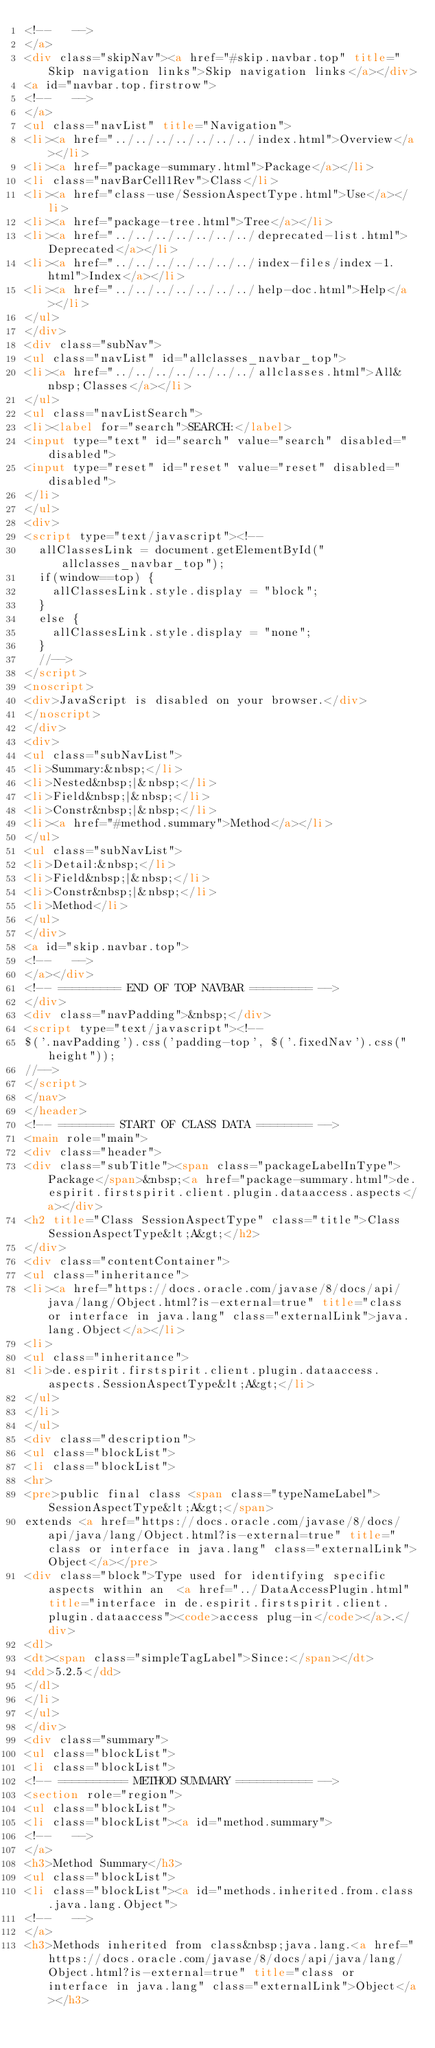Convert code to text. <code><loc_0><loc_0><loc_500><loc_500><_HTML_><!--   -->
</a>
<div class="skipNav"><a href="#skip.navbar.top" title="Skip navigation links">Skip navigation links</a></div>
<a id="navbar.top.firstrow">
<!--   -->
</a>
<ul class="navList" title="Navigation">
<li><a href="../../../../../../../index.html">Overview</a></li>
<li><a href="package-summary.html">Package</a></li>
<li class="navBarCell1Rev">Class</li>
<li><a href="class-use/SessionAspectType.html">Use</a></li>
<li><a href="package-tree.html">Tree</a></li>
<li><a href="../../../../../../../deprecated-list.html">Deprecated</a></li>
<li><a href="../../../../../../../index-files/index-1.html">Index</a></li>
<li><a href="../../../../../../../help-doc.html">Help</a></li>
</ul>
</div>
<div class="subNav">
<ul class="navList" id="allclasses_navbar_top">
<li><a href="../../../../../../../allclasses.html">All&nbsp;Classes</a></li>
</ul>
<ul class="navListSearch">
<li><label for="search">SEARCH:</label>
<input type="text" id="search" value="search" disabled="disabled">
<input type="reset" id="reset" value="reset" disabled="disabled">
</li>
</ul>
<div>
<script type="text/javascript"><!--
  allClassesLink = document.getElementById("allclasses_navbar_top");
  if(window==top) {
    allClassesLink.style.display = "block";
  }
  else {
    allClassesLink.style.display = "none";
  }
  //-->
</script>
<noscript>
<div>JavaScript is disabled on your browser.</div>
</noscript>
</div>
<div>
<ul class="subNavList">
<li>Summary:&nbsp;</li>
<li>Nested&nbsp;|&nbsp;</li>
<li>Field&nbsp;|&nbsp;</li>
<li>Constr&nbsp;|&nbsp;</li>
<li><a href="#method.summary">Method</a></li>
</ul>
<ul class="subNavList">
<li>Detail:&nbsp;</li>
<li>Field&nbsp;|&nbsp;</li>
<li>Constr&nbsp;|&nbsp;</li>
<li>Method</li>
</ul>
</div>
<a id="skip.navbar.top">
<!--   -->
</a></div>
<!-- ========= END OF TOP NAVBAR ========= -->
</div>
<div class="navPadding">&nbsp;</div>
<script type="text/javascript"><!--
$('.navPadding').css('padding-top', $('.fixedNav').css("height"));
//-->
</script>
</nav>
</header>
<!-- ======== START OF CLASS DATA ======== -->
<main role="main">
<div class="header">
<div class="subTitle"><span class="packageLabelInType">Package</span>&nbsp;<a href="package-summary.html">de.espirit.firstspirit.client.plugin.dataaccess.aspects</a></div>
<h2 title="Class SessionAspectType" class="title">Class SessionAspectType&lt;A&gt;</h2>
</div>
<div class="contentContainer">
<ul class="inheritance">
<li><a href="https://docs.oracle.com/javase/8/docs/api/java/lang/Object.html?is-external=true" title="class or interface in java.lang" class="externalLink">java.lang.Object</a></li>
<li>
<ul class="inheritance">
<li>de.espirit.firstspirit.client.plugin.dataaccess.aspects.SessionAspectType&lt;A&gt;</li>
</ul>
</li>
</ul>
<div class="description">
<ul class="blockList">
<li class="blockList">
<hr>
<pre>public final class <span class="typeNameLabel">SessionAspectType&lt;A&gt;</span>
extends <a href="https://docs.oracle.com/javase/8/docs/api/java/lang/Object.html?is-external=true" title="class or interface in java.lang" class="externalLink">Object</a></pre>
<div class="block">Type used for identifying specific aspects within an  <a href="../DataAccessPlugin.html" title="interface in de.espirit.firstspirit.client.plugin.dataaccess"><code>access plug-in</code></a>.</div>
<dl>
<dt><span class="simpleTagLabel">Since:</span></dt>
<dd>5.2.5</dd>
</dl>
</li>
</ul>
</div>
<div class="summary">
<ul class="blockList">
<li class="blockList">
<!-- ========== METHOD SUMMARY =========== -->
<section role="region">
<ul class="blockList">
<li class="blockList"><a id="method.summary">
<!--   -->
</a>
<h3>Method Summary</h3>
<ul class="blockList">
<li class="blockList"><a id="methods.inherited.from.class.java.lang.Object">
<!--   -->
</a>
<h3>Methods inherited from class&nbsp;java.lang.<a href="https://docs.oracle.com/javase/8/docs/api/java/lang/Object.html?is-external=true" title="class or interface in java.lang" class="externalLink">Object</a></h3></code> 